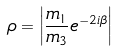Convert formula to latex. <formula><loc_0><loc_0><loc_500><loc_500>\rho = \left | \frac { m _ { 1 } } { m _ { 3 } } e ^ { - 2 i \beta } \right |</formula> 